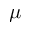<formula> <loc_0><loc_0><loc_500><loc_500>\mu</formula> 